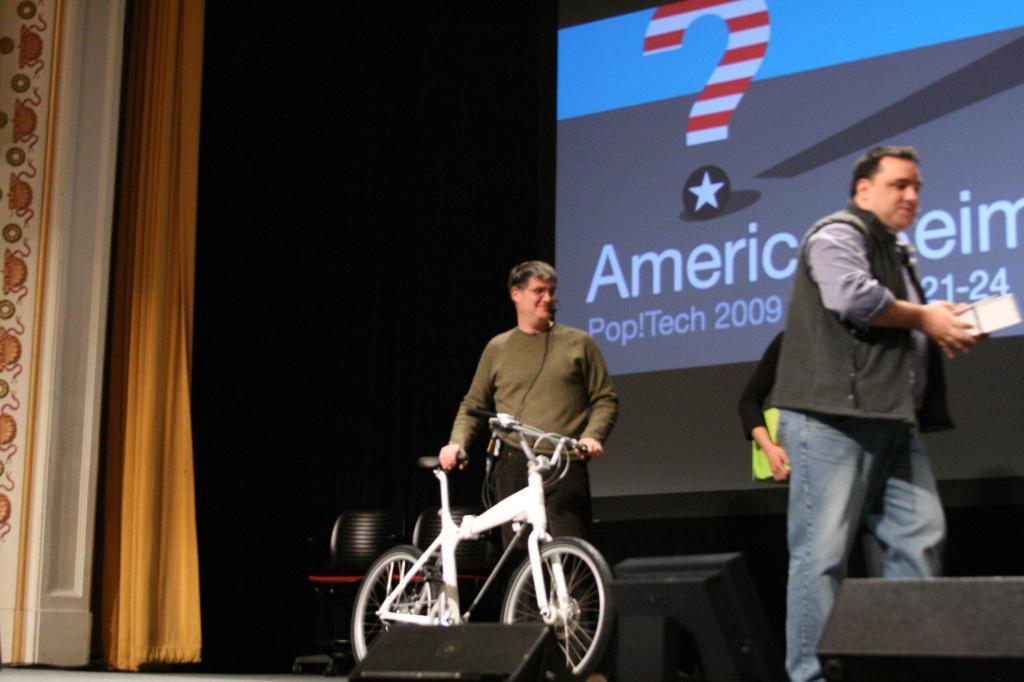How would you summarize this image in a sentence or two? In this image there are three persons, the persons are holding an object, there is a bicycle, there are objects truncated towards the bottom of the image, there is a curtain truncated towards the top of the image, there is an object truncated towards the left of the image, there is a screen truncated towards the top of the image, the background of the image is dark. 